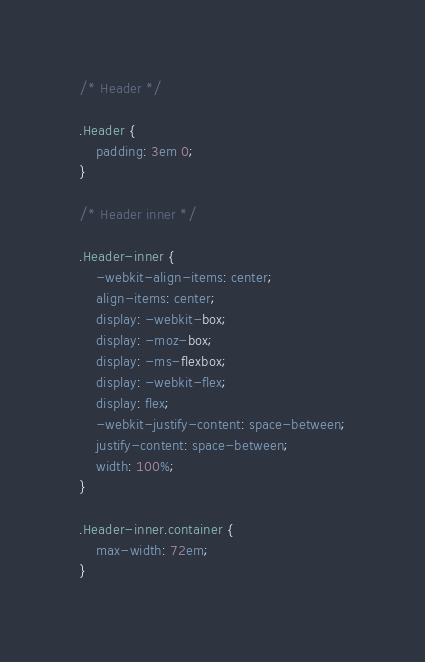Convert code to text. <code><loc_0><loc_0><loc_500><loc_500><_CSS_>
/* Header */

.Header {
	padding: 3em 0;
}

/* Header inner */

.Header-inner {
	-webkit-align-items: center;
	align-items: center;
	display: -webkit-box;
	display: -moz-box;
	display: -ms-flexbox;
	display: -webkit-flex;
	display: flex;
	-webkit-justify-content: space-between;
	justify-content: space-between;
	width: 100%;
}

.Header-inner.container {
	max-width: 72em;
}</code> 